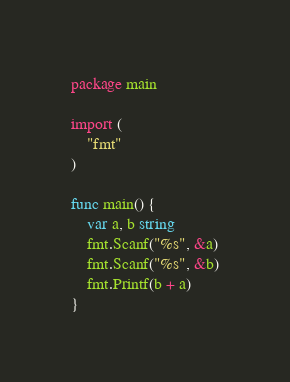<code> <loc_0><loc_0><loc_500><loc_500><_Go_>package main

import (
	"fmt"
)

func main() {
	var a, b string
	fmt.Scanf("%s", &a)
   	fmt.Scanf("%s", &b)
	fmt.Printf(b + a)
}</code> 